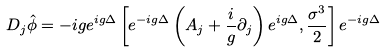Convert formula to latex. <formula><loc_0><loc_0><loc_500><loc_500>D _ { j } \hat { \phi } = - i g e ^ { i g \Delta } \left [ e ^ { - i g \Delta } \left ( A _ { j } + \frac { i } { g } \partial _ { j } \right ) e ^ { i g \Delta } , \frac { \sigma ^ { 3 } } { 2 } \right ] e ^ { - i g \Delta }</formula> 